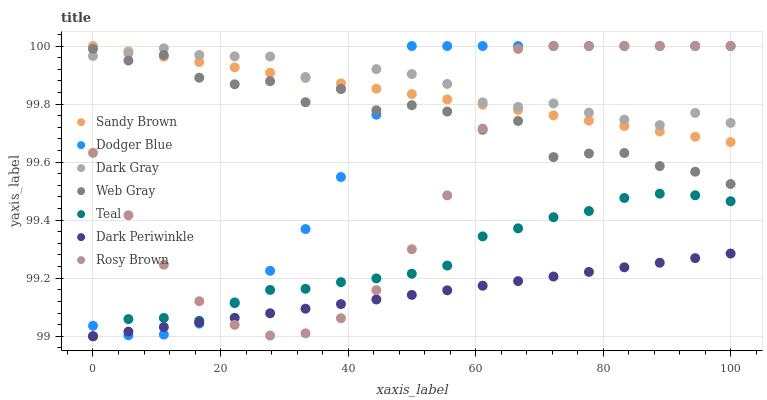Does Dark Periwinkle have the minimum area under the curve?
Answer yes or no. Yes. Does Dark Gray have the maximum area under the curve?
Answer yes or no. Yes. Does Rosy Brown have the minimum area under the curve?
Answer yes or no. No. Does Rosy Brown have the maximum area under the curve?
Answer yes or no. No. Is Dark Periwinkle the smoothest?
Answer yes or no. Yes. Is Web Gray the roughest?
Answer yes or no. Yes. Is Rosy Brown the smoothest?
Answer yes or no. No. Is Rosy Brown the roughest?
Answer yes or no. No. Does Teal have the lowest value?
Answer yes or no. Yes. Does Rosy Brown have the lowest value?
Answer yes or no. No. Does Sandy Brown have the highest value?
Answer yes or no. Yes. Does Dark Gray have the highest value?
Answer yes or no. No. Is Dark Periwinkle less than Web Gray?
Answer yes or no. Yes. Is Sandy Brown greater than Dark Periwinkle?
Answer yes or no. Yes. Does Dark Periwinkle intersect Teal?
Answer yes or no. Yes. Is Dark Periwinkle less than Teal?
Answer yes or no. No. Is Dark Periwinkle greater than Teal?
Answer yes or no. No. Does Dark Periwinkle intersect Web Gray?
Answer yes or no. No. 